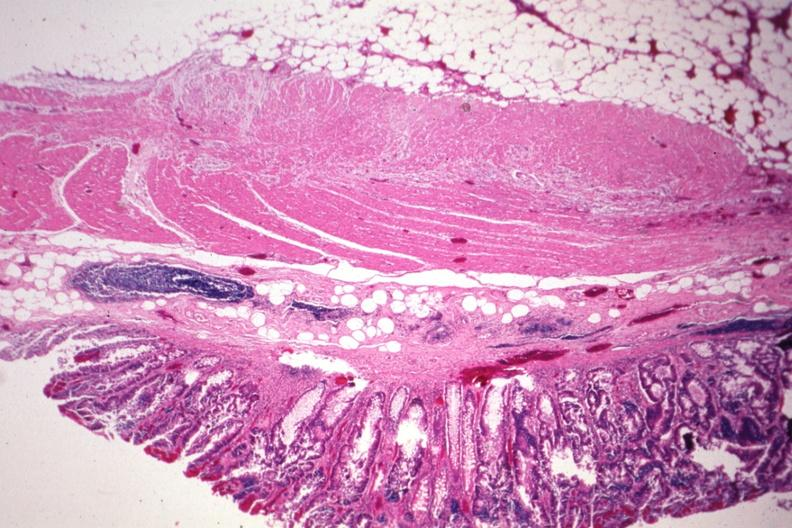s papillary intraductal adenocarcinoma present?
Answer the question using a single word or phrase. No 